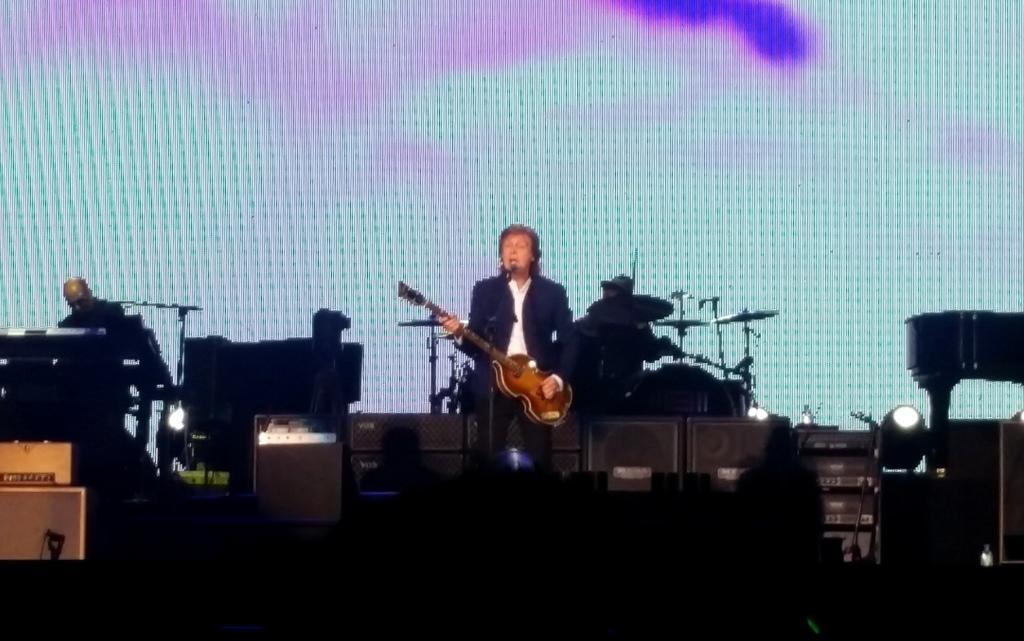How would you summarize this image in a sentence or two? In this picture I can observe three members playing musical instruments on the stage. In the background I can observe screen. 